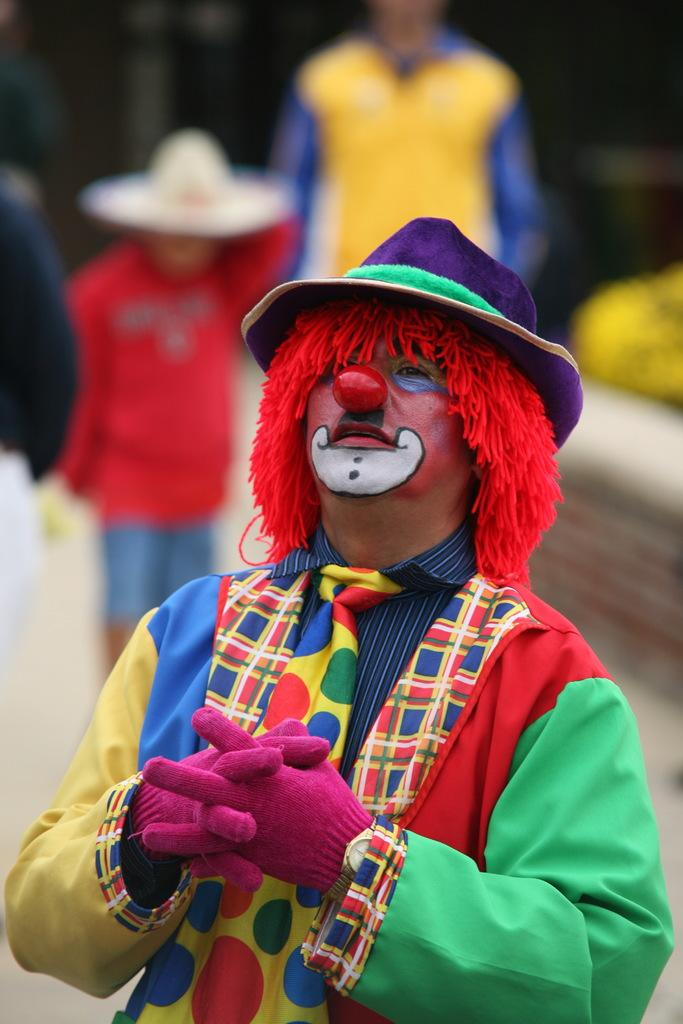What is the main subject of the image? There is a person wearing a joker costume in the image. Are there any other people in the image? Yes, there are two other persons standing behind the person in the joker costume. What type of glass is the person in the joker costume holding in the image? There is no glass present in the image; the person in the joker costume is not holding any object. 